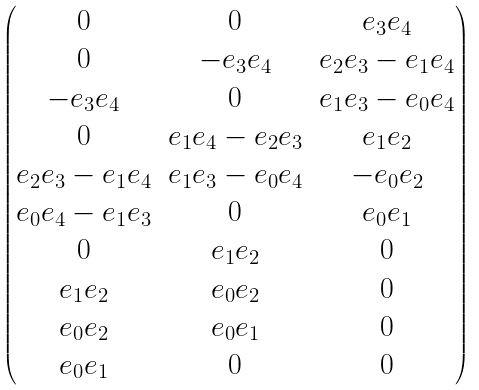Convert formula to latex. <formula><loc_0><loc_0><loc_500><loc_500>\begin{pmatrix} 0 & 0 & { e } _ { 3 } { e } _ { 4 } \\ 0 & { - { e } _ { 3 } { e } _ { 4 } } & { e } _ { 2 } { e } _ { 3 } - { e } _ { 1 } { e } _ { 4 } \\ { - { e } _ { 3 } { e } _ { 4 } } & 0 & { e } _ { 1 } { e } _ { 3 } - { e } _ { 0 } { e } _ { 4 } \\ 0 & { e } _ { 1 } { e } _ { 4 } - { e } _ { 2 } { e } _ { 3 } & { e } _ { 1 } { e } _ { 2 } \\ { e } _ { 2 } { e } _ { 3 } - { e } _ { 1 } { e } _ { 4 } & { e } _ { 1 } { e } _ { 3 } - { e } _ { 0 } { e } _ { 4 } & { - { e } _ { 0 } { e } _ { 2 } } \\ { e } _ { 0 } { e } _ { 4 } - { e } _ { 1 } { e } _ { 3 } & 0 & { e } _ { 0 } { e } _ { 1 } \\ 0 & { e } _ { 1 } { e } _ { 2 } & 0 \\ { e } _ { 1 } { e } _ { 2 } & { e } _ { 0 } { e } _ { 2 } & 0 \\ { e } _ { 0 } { e } _ { 2 } & { e } _ { 0 } { e } _ { 1 } & 0 \\ { e } _ { 0 } { e } _ { 1 } & 0 & 0 \\ \end{pmatrix}</formula> 